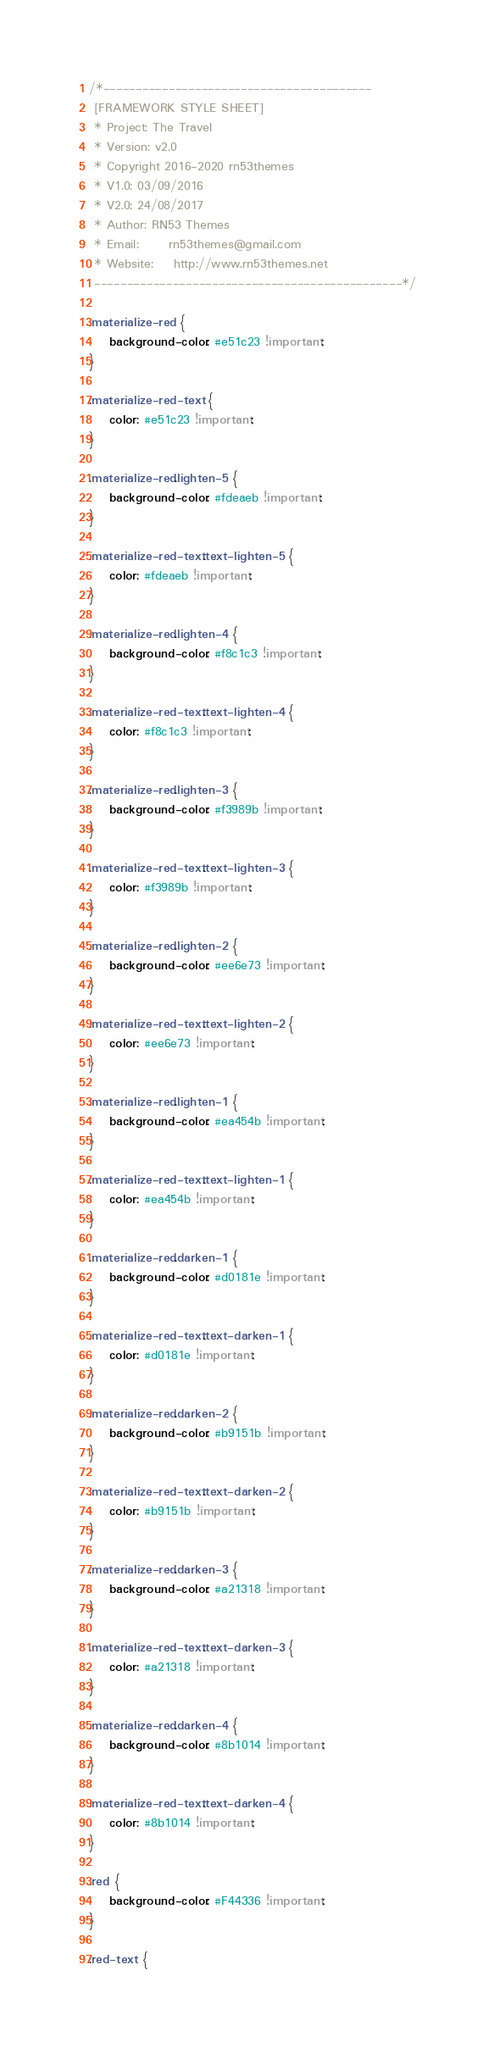<code> <loc_0><loc_0><loc_500><loc_500><_CSS_>/*-----------------------------------------
 [FRAMEWORK STYLE SHEET]
 * Project: The Travel
 * Version: v2.0
 * Copyright 2016-2020 rn53themes
 * V1.0: 03/09/2016
 * V2.0: 24/08/2017
 * Author: RN53 Themes
 * Email:      rn53themes@gmail.com
 * Website:    http://www.rn53themes.net
 -----------------------------------------------*/

.materialize-red {
    background-color: #e51c23 !important;
}

.materialize-red-text {
    color: #e51c23 !important;
}

.materialize-red.lighten-5 {
    background-color: #fdeaeb !important;
}

.materialize-red-text.text-lighten-5 {
    color: #fdeaeb !important;
}

.materialize-red.lighten-4 {
    background-color: #f8c1c3 !important;
}

.materialize-red-text.text-lighten-4 {
    color: #f8c1c3 !important;
}

.materialize-red.lighten-3 {
    background-color: #f3989b !important;
}

.materialize-red-text.text-lighten-3 {
    color: #f3989b !important;
}

.materialize-red.lighten-2 {
    background-color: #ee6e73 !important;
}

.materialize-red-text.text-lighten-2 {
    color: #ee6e73 !important;
}

.materialize-red.lighten-1 {
    background-color: #ea454b !important;
}

.materialize-red-text.text-lighten-1 {
    color: #ea454b !important;
}

.materialize-red.darken-1 {
    background-color: #d0181e !important;
}

.materialize-red-text.text-darken-1 {
    color: #d0181e !important;
}

.materialize-red.darken-2 {
    background-color: #b9151b !important;
}

.materialize-red-text.text-darken-2 {
    color: #b9151b !important;
}

.materialize-red.darken-3 {
    background-color: #a21318 !important;
}

.materialize-red-text.text-darken-3 {
    color: #a21318 !important;
}

.materialize-red.darken-4 {
    background-color: #8b1014 !important;
}

.materialize-red-text.text-darken-4 {
    color: #8b1014 !important;
}

.red {
    background-color: #F44336 !important;
}

.red-text {</code> 